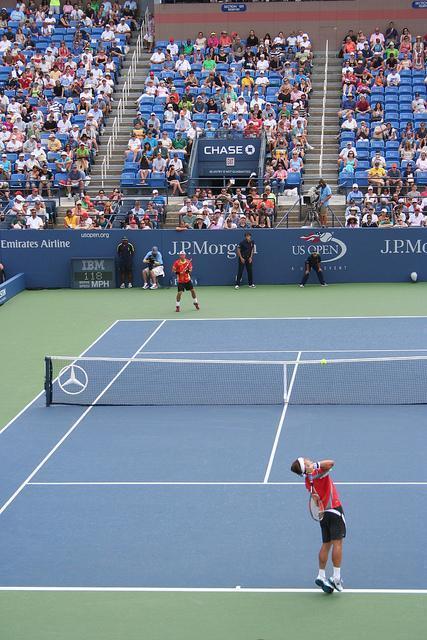How many people can you see?
Give a very brief answer. 2. 